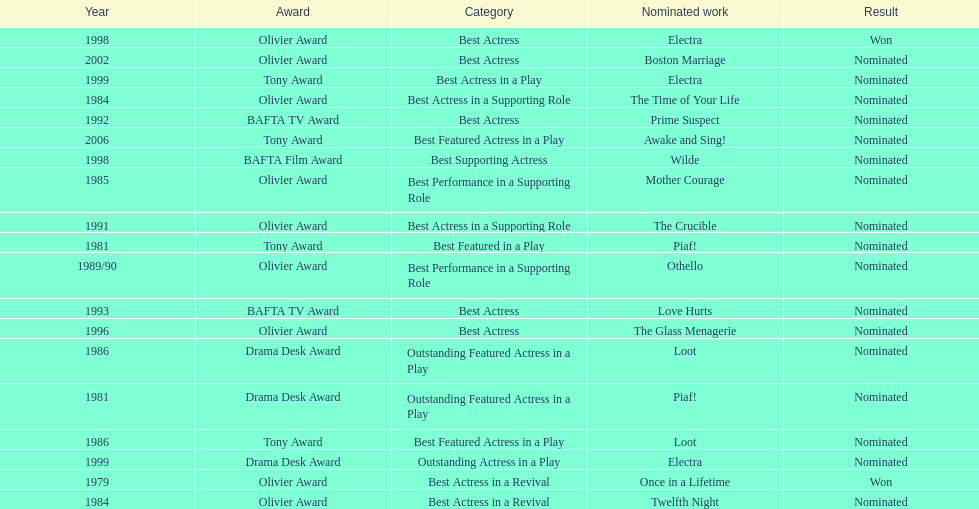What award did once in a lifetime win? Best Actress in a Revival. 